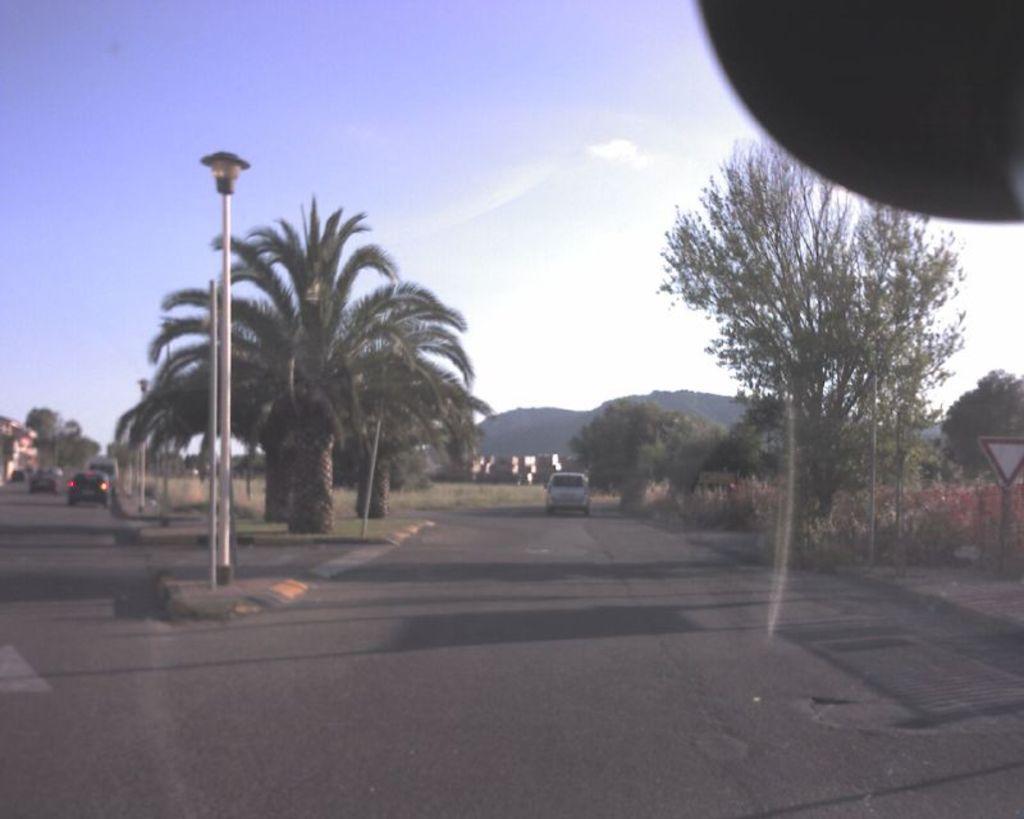Can you describe this image briefly? In the foreground of this image, there are roads, poles, a board, trees, plants, vehicles moving on the road and in the background, there are mountains and the sky. 